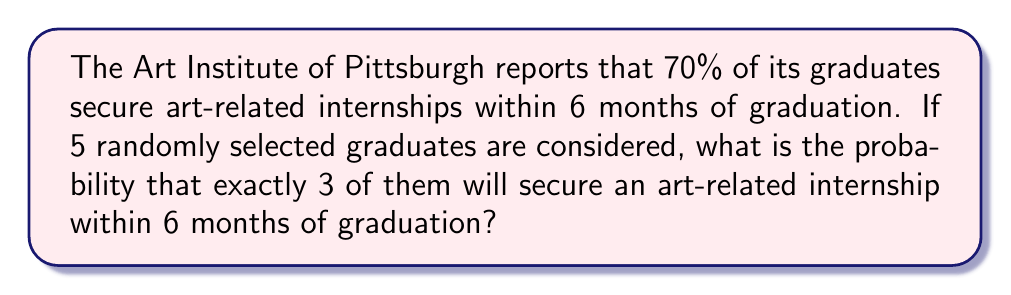Give your solution to this math problem. To solve this problem, we'll use the binomial probability formula:

$$P(X = k) = \binom{n}{k} p^k (1-p)^{n-k}$$

Where:
$n$ = number of trials (graduates) = 5
$k$ = number of successes (graduates securing internships) = 3
$p$ = probability of success for each trial = 0.70

Step 1: Calculate the binomial coefficient
$$\binom{5}{3} = \frac{5!}{3!(5-3)!} = \frac{5 \cdot 4}{2 \cdot 1} = 10$$

Step 2: Calculate $p^k$
$$0.70^3 = 0.343$$

Step 3: Calculate $(1-p)^{n-k}$
$$(1-0.70)^{5-3} = 0.30^2 = 0.09$$

Step 4: Multiply all components
$$10 \cdot 0.343 \cdot 0.09 = 0.3087$$

Therefore, the probability of exactly 3 out of 5 randomly selected graduates securing an art-related internship within 6 months is approximately 0.3087 or 30.87%.
Answer: $0.3087$ or $30.87\%$ 